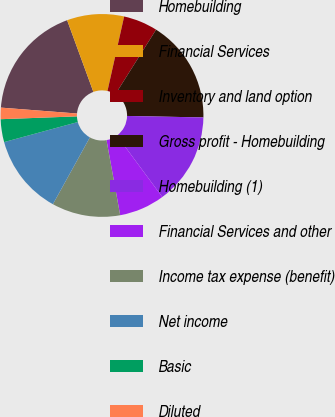Convert chart. <chart><loc_0><loc_0><loc_500><loc_500><pie_chart><fcel>Homebuilding<fcel>Financial Services<fcel>Inventory and land option<fcel>Gross profit - Homebuilding<fcel>Homebuilding (1)<fcel>Financial Services and other<fcel>Income tax expense (benefit)<fcel>Net income<fcel>Basic<fcel>Diluted<nl><fcel>18.18%<fcel>9.09%<fcel>5.45%<fcel>16.36%<fcel>14.55%<fcel>7.27%<fcel>10.91%<fcel>12.73%<fcel>3.64%<fcel>1.82%<nl></chart> 